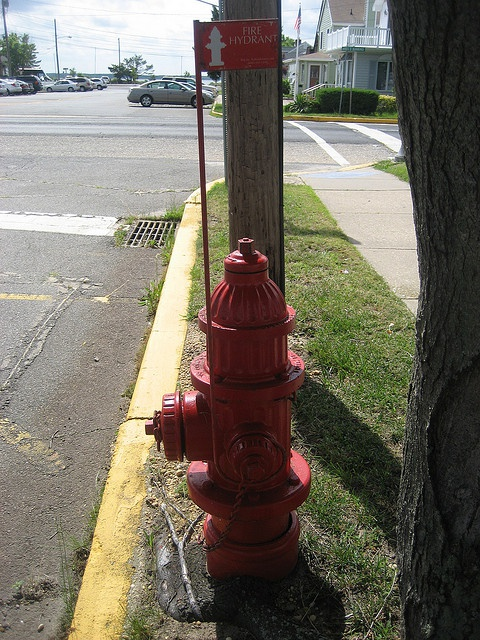Describe the objects in this image and their specific colors. I can see fire hydrant in darkgray, black, maroon, lightpink, and brown tones, car in darkgray, gray, black, and lightgray tones, car in darkgray, gray, and lightgray tones, car in darkgray, gray, navy, and lightgray tones, and car in darkgray, navy, darkblue, black, and gray tones in this image. 